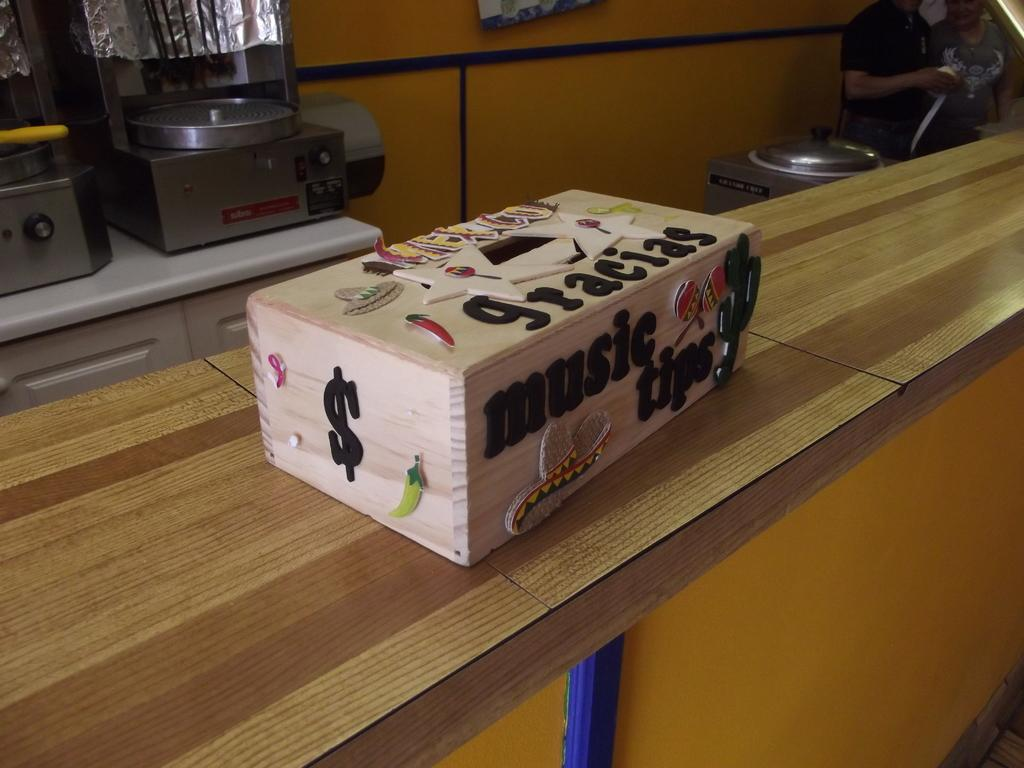<image>
Relay a brief, clear account of the picture shown. A suggestion box is labeled with "music tips" and "gracias". 